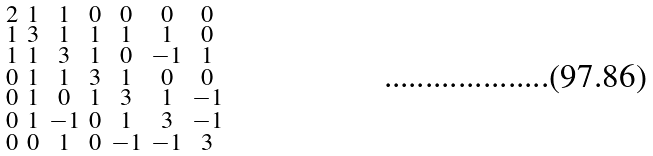Convert formula to latex. <formula><loc_0><loc_0><loc_500><loc_500>\begin{smallmatrix} 2 & 1 & 1 & 0 & 0 & 0 & 0 \\ 1 & 3 & 1 & 1 & 1 & 1 & 0 \\ 1 & 1 & 3 & 1 & 0 & - 1 & 1 \\ 0 & 1 & 1 & 3 & 1 & 0 & 0 \\ 0 & 1 & 0 & 1 & 3 & 1 & - 1 \\ 0 & 1 & - 1 & 0 & 1 & 3 & - 1 \\ 0 & 0 & 1 & 0 & - 1 & - 1 & 3 \end{smallmatrix}</formula> 